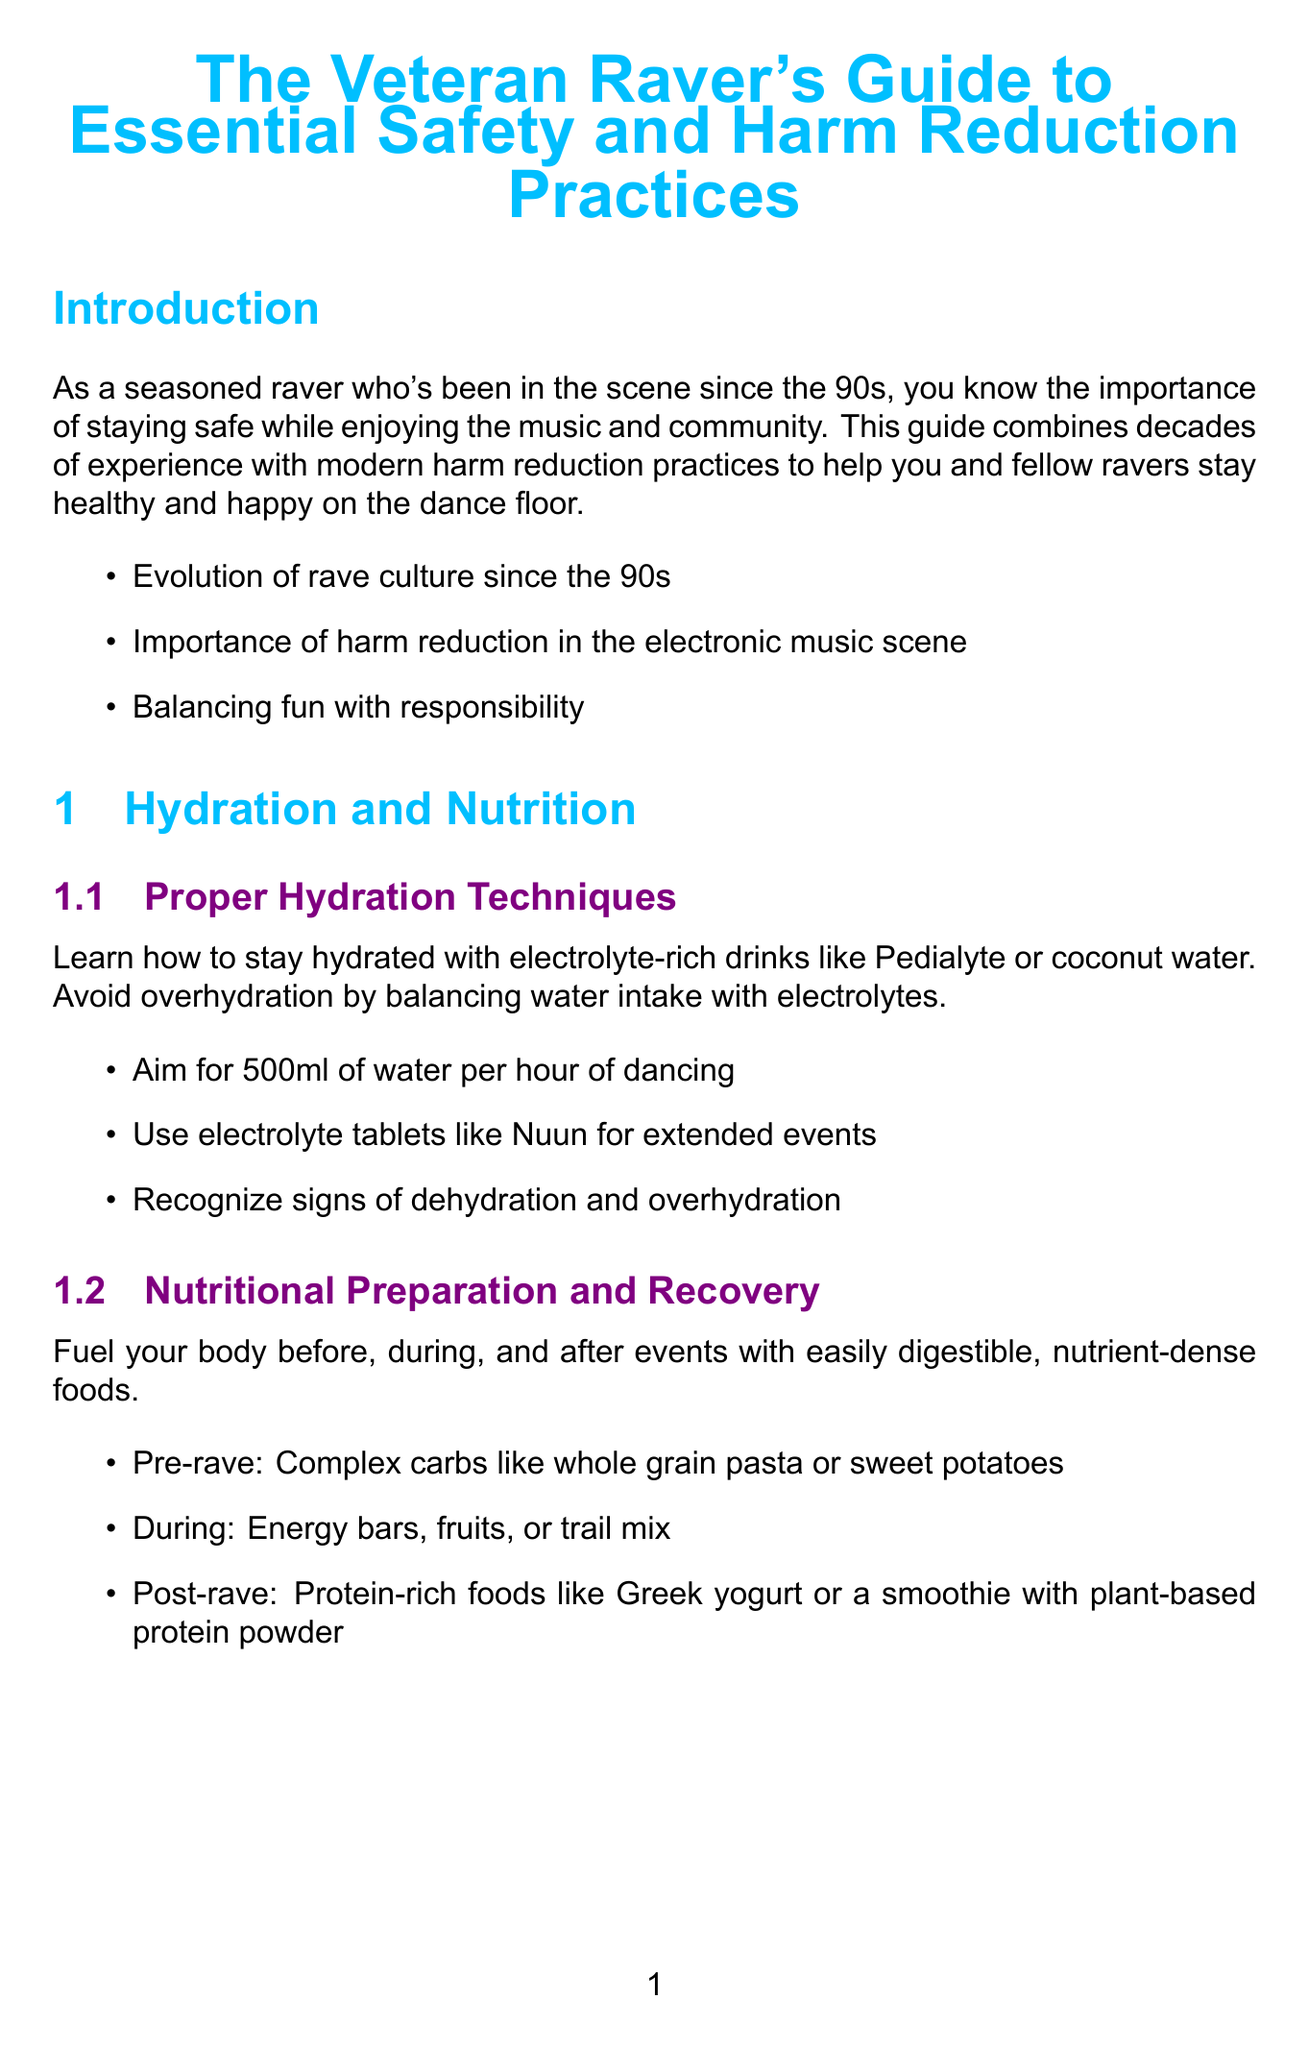What is the title of the manual? The title can be found at the beginning of the document.
Answer: The Veteran Raver's Guide to Essential Safety and Harm Reduction Practices How many chapters are there in the manual? The number of chapters is listed in the document's structure.
Answer: Five What should you aim for in terms of water intake per hour of dancing? This figure is specified in the hydration section of the manual.
Answer: 500ml Which organization provides substance testing kits? The name of the organization is mentioned in the substance use safety section.
Answer: DanceSafe What is one key point about maintaining mental wellbeing? The key points are included in the mental health section of the manual.
Answer: Practice integration after transformative experiences What can be included in a rave recovery kit? The contents of the recovery kit are listed in the physical wellness chapter.
Answer: Magnesium supplements for muscle recovery What type of earplugs are recommended? Recommended products for hearing protection are listed in the relevant section.
Answer: EarPeace HD Concert Earplugs In what position should you place an unconscious person? This response is detailed in the emergency response section of the manual.
Answer: Recovery position What is emphasized as important in the introduction of the manual? Key points in the introduction summarize the main messages.
Answer: Harm reduction in the electronic music scene 